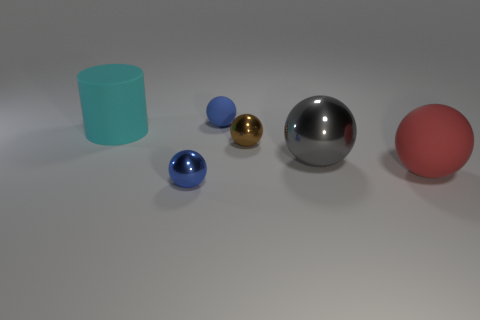Subtract all tiny blue balls. How many balls are left? 3 Subtract all gray spheres. How many spheres are left? 4 Add 3 tiny matte objects. How many objects exist? 9 Subtract all balls. How many objects are left? 1 Subtract 0 yellow cylinders. How many objects are left? 6 Subtract 4 balls. How many balls are left? 1 Subtract all gray spheres. Subtract all brown cubes. How many spheres are left? 4 Subtract all yellow blocks. How many red balls are left? 1 Subtract all red balls. Subtract all large metal objects. How many objects are left? 4 Add 5 tiny metal spheres. How many tiny metal spheres are left? 7 